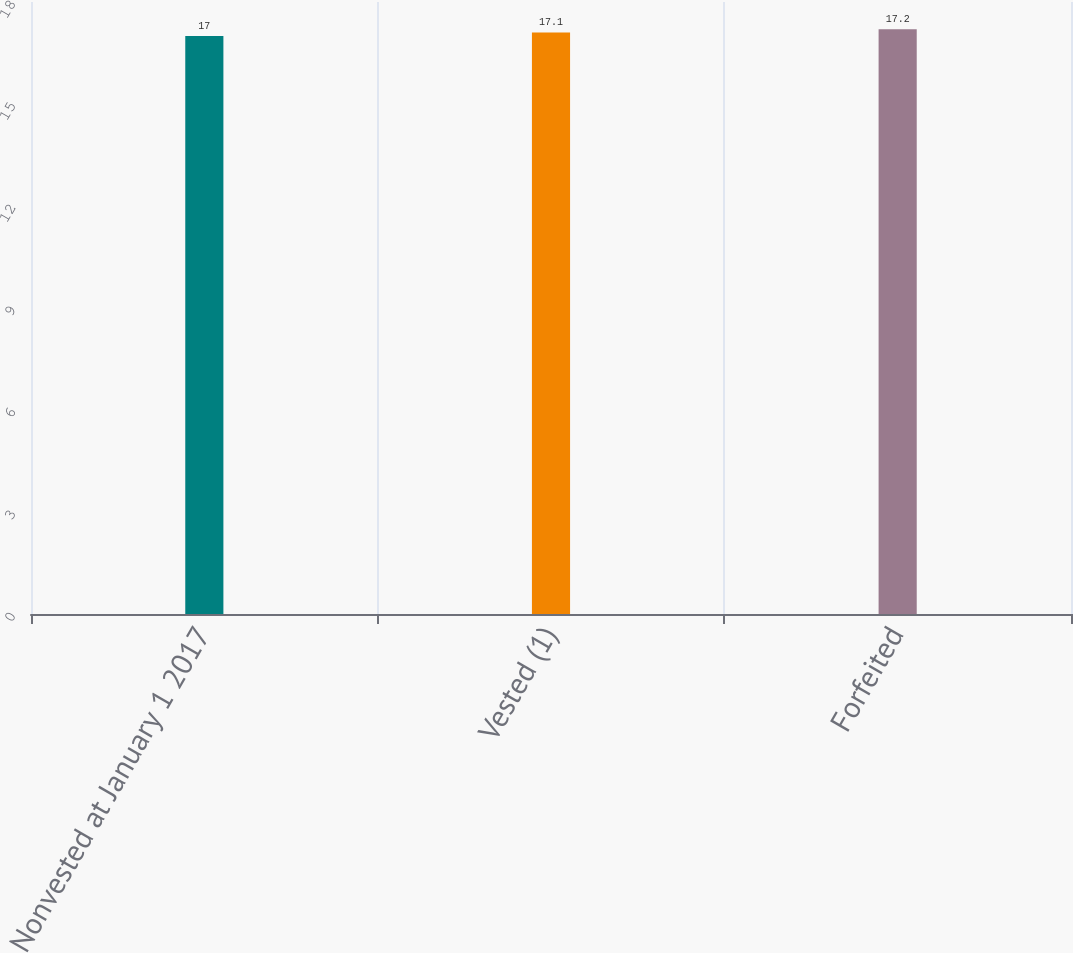Convert chart. <chart><loc_0><loc_0><loc_500><loc_500><bar_chart><fcel>Nonvested at January 1 2017<fcel>Vested (1)<fcel>Forfeited<nl><fcel>17<fcel>17.1<fcel>17.2<nl></chart> 